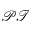Convert formula to latex. <formula><loc_0><loc_0><loc_500><loc_500>\mathcal { P T }</formula> 